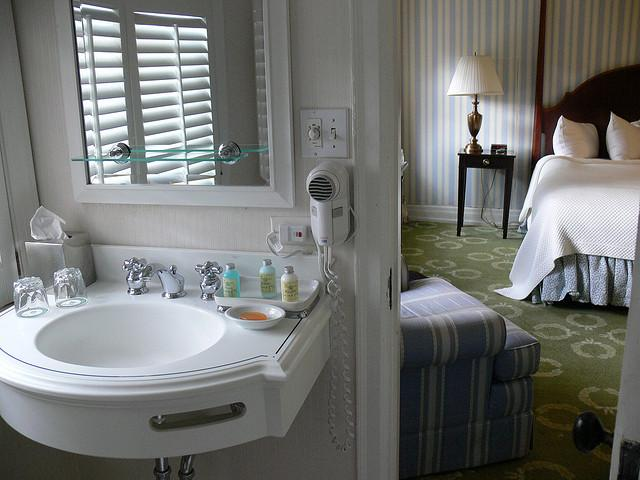What is the corded device called that's on the wall? Please explain your reasoning. hair dryer. Hair dryers often are stored on hotel room walls and have curly cords. 